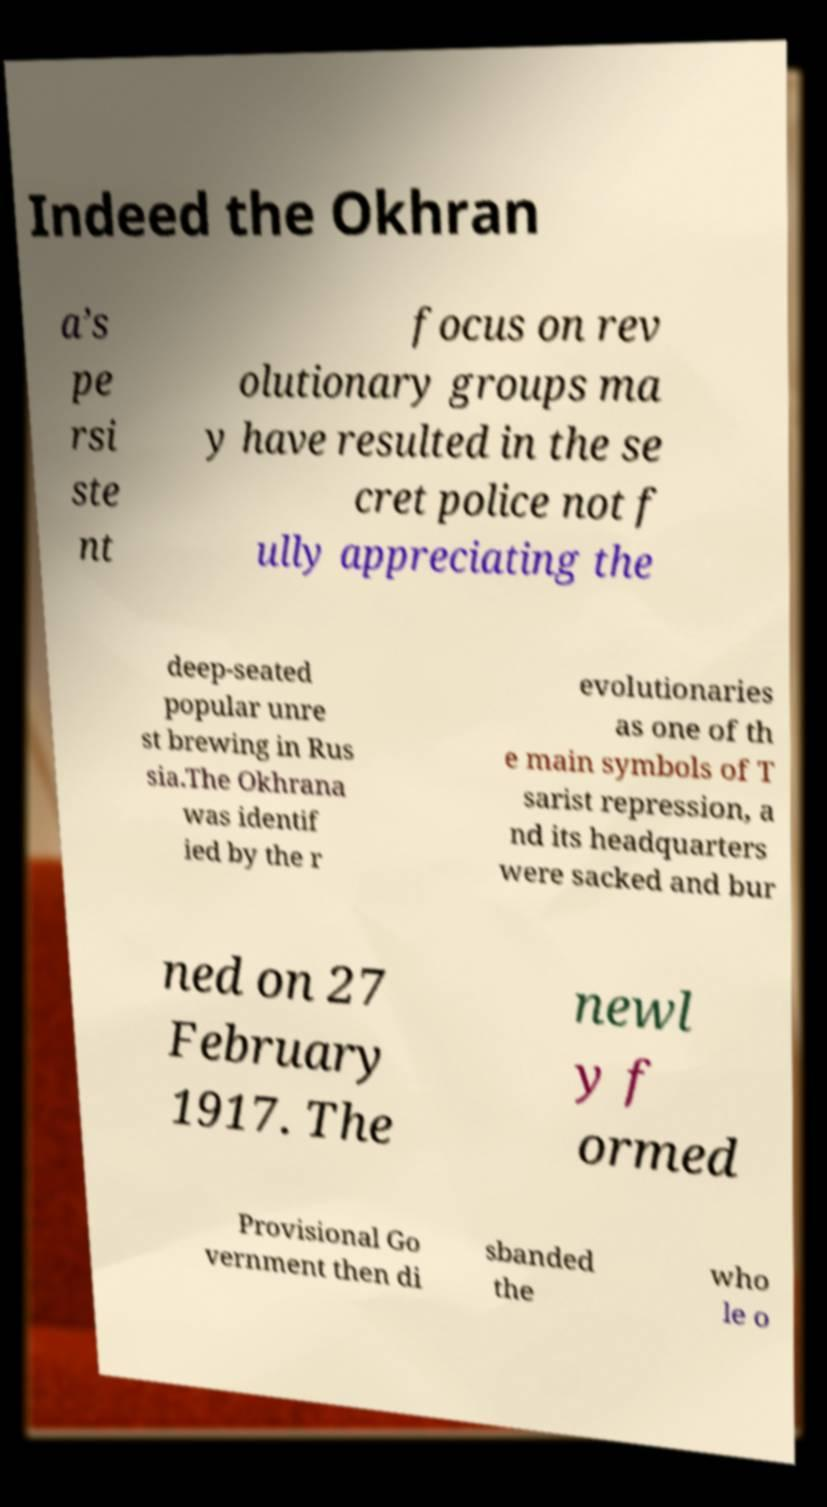There's text embedded in this image that I need extracted. Can you transcribe it verbatim? Indeed the Okhran a’s pe rsi ste nt focus on rev olutionary groups ma y have resulted in the se cret police not f ully appreciating the deep-seated popular unre st brewing in Rus sia.The Okhrana was identif ied by the r evolutionaries as one of th e main symbols of T sarist repression, a nd its headquarters were sacked and bur ned on 27 February 1917. The newl y f ormed Provisional Go vernment then di sbanded the who le o 